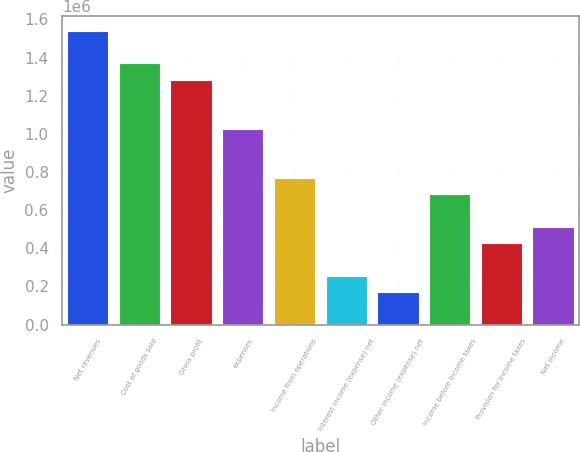Convert chart to OTSL. <chart><loc_0><loc_0><loc_500><loc_500><bar_chart><fcel>Net revenues<fcel>Cost of goods sold<fcel>Gross profit<fcel>expenses<fcel>Income from operations<fcel>Interest income (expense) net<fcel>Other income (expense) net<fcel>Income before income taxes<fcel>Provision for income taxes<fcel>Net income<nl><fcel>1.54154e+06<fcel>1.37026e+06<fcel>1.28462e+06<fcel>1.02769e+06<fcel>770770<fcel>256924<fcel>171283<fcel>685129<fcel>428206<fcel>513847<nl></chart> 